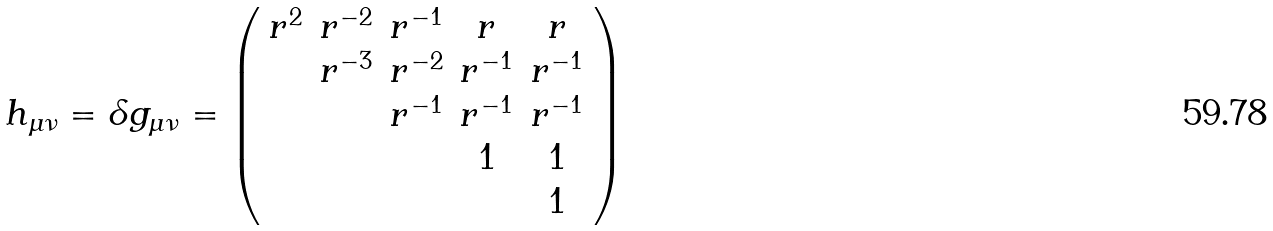<formula> <loc_0><loc_0><loc_500><loc_500>h _ { \mu \nu } = \delta g _ { \mu \nu } = \left ( \begin{array} { c c c c c } r ^ { 2 } & r ^ { - 2 } & r ^ { - 1 } & r & r \\ & r ^ { - 3 } & r ^ { - 2 } & r ^ { - 1 } & r ^ { - 1 } \\ & & r ^ { - 1 } & r ^ { - 1 } & r ^ { - 1 } \\ & & & 1 & 1 \\ & & & & 1 \end{array} \right )</formula> 